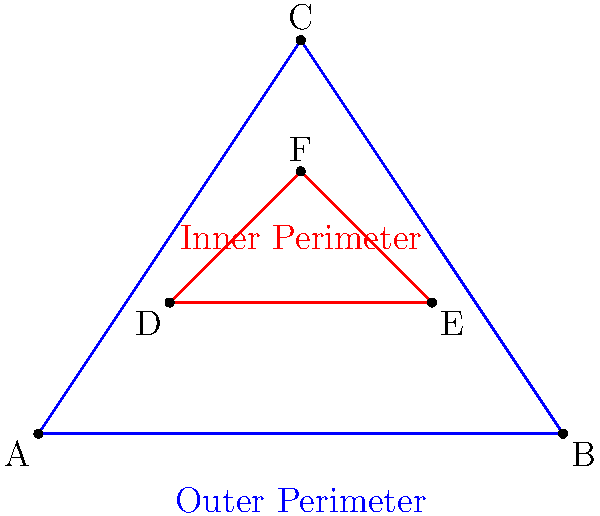A sensitive facility is protected by two perimeters: an outer triangular fence (ABC) and an inner triangular security barrier (DEF). If the area of the outer perimeter is 6 square units and the area of the inner perimeter is 1 square unit, what is the ratio of the side lengths of the outer perimeter to the inner perimeter? Let's approach this step-by-step:

1) For similar triangles, the ratio of their areas is equal to the square of the ratio of their side lengths. Let's call this ratio $r$.

2) We can express this mathematically as:
   $$\frac{\text{Area of ABC}}{\text{Area of DEF}} = r^2$$

3) We're given that the area of ABC is 6 square units and the area of DEF is 1 square unit. Let's substitute these values:
   $$\frac{6}{1} = r^2$$

4) Simplify:
   $$6 = r^2$$

5) Take the square root of both sides:
   $$\sqrt{6} = r$$

6) Simplify:
   $$r = \sqrt{6} \approx 2.449$$

Therefore, the ratio of the side lengths of the outer perimeter to the inner perimeter is $\sqrt{6}$ : 1.
Answer: $\sqrt{6}$ : 1 